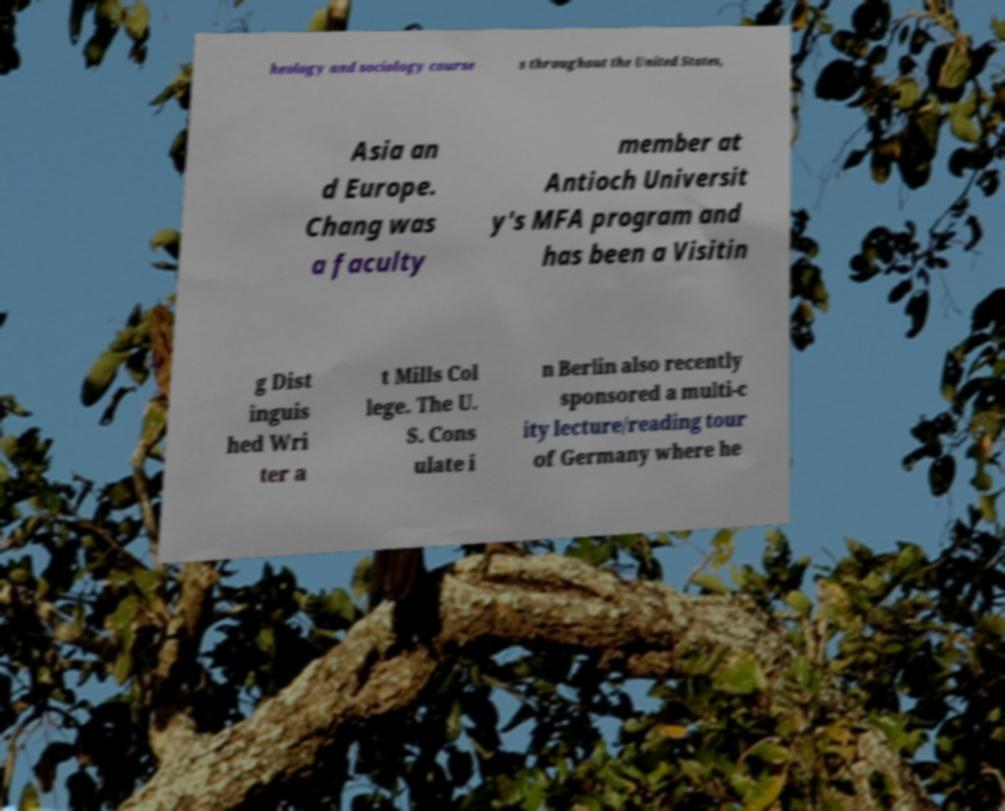Please identify and transcribe the text found in this image. heology and sociology course s throughout the United States, Asia an d Europe. Chang was a faculty member at Antioch Universit y's MFA program and has been a Visitin g Dist inguis hed Wri ter a t Mills Col lege. The U. S. Cons ulate i n Berlin also recently sponsored a multi-c ity lecture/reading tour of Germany where he 